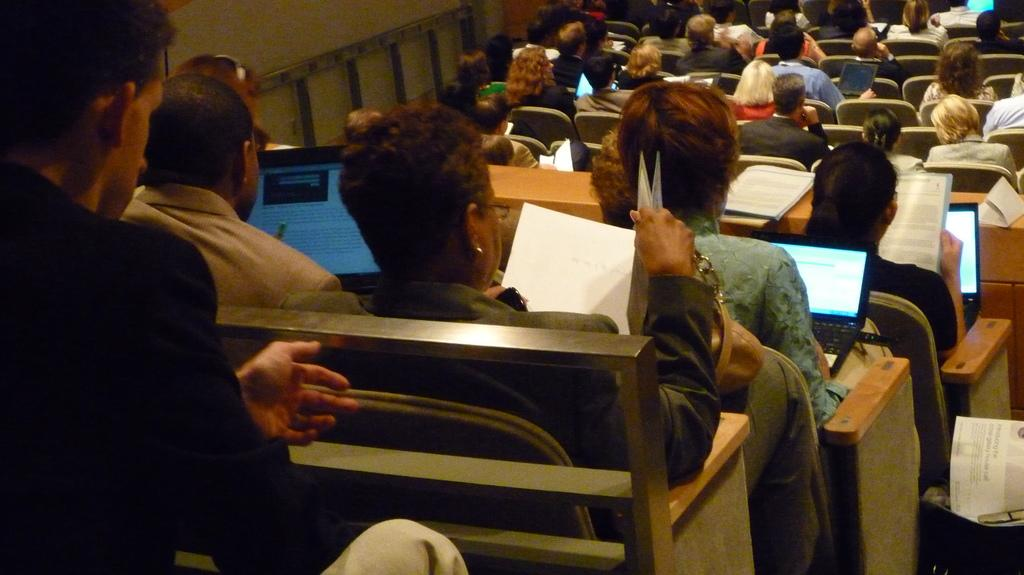What are the people in the image doing? People are sitting on chairs in the image. What objects are in front of the chairs? There are tables in front of the chairs. What electronic devices are on the tables? Laptops are present on the tables. What are some people holding in their hands? Some people are holding books. Can you see the grandfather waving at the people in the image? There is no grandfather or waving present in the image. What type of food is being bitten by the people in the image? There is no food or biting present in the image. 